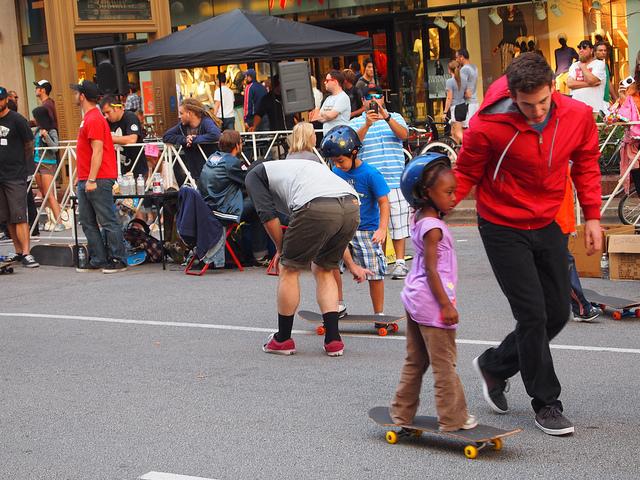Are the people in the foreground a couple?
Write a very short answer. No. What color is the tent?
Short answer required. Black. Who is skating?
Be succinct. Child. Is the man on the right shirtless?
Short answer required. No. What kind of event is this?
Short answer required. Skateboarding. How many men are wearing scarves?
Keep it brief. 0. What are the people riding through the market?
Short answer required. Skateboards. What is the kids rolling?
Answer briefly. Skateboard. Do you see stuffed animals?
Keep it brief. No. How many stop lights are visible?
Give a very brief answer. 0. What color shirt is the girl wearing?
Short answer required. Pink. What is the weather pictured?
Concise answer only. Sunny. What color is the jacket of the man closest to the camera?
Quick response, please. Red. How are the women carrying their children to the market?
Quick response, please. Skateboard. What are the kids riding?
Quick response, please. Skateboard. What is the woman in the pink shirt doing with the man's hand?
Short answer required. Holding. 